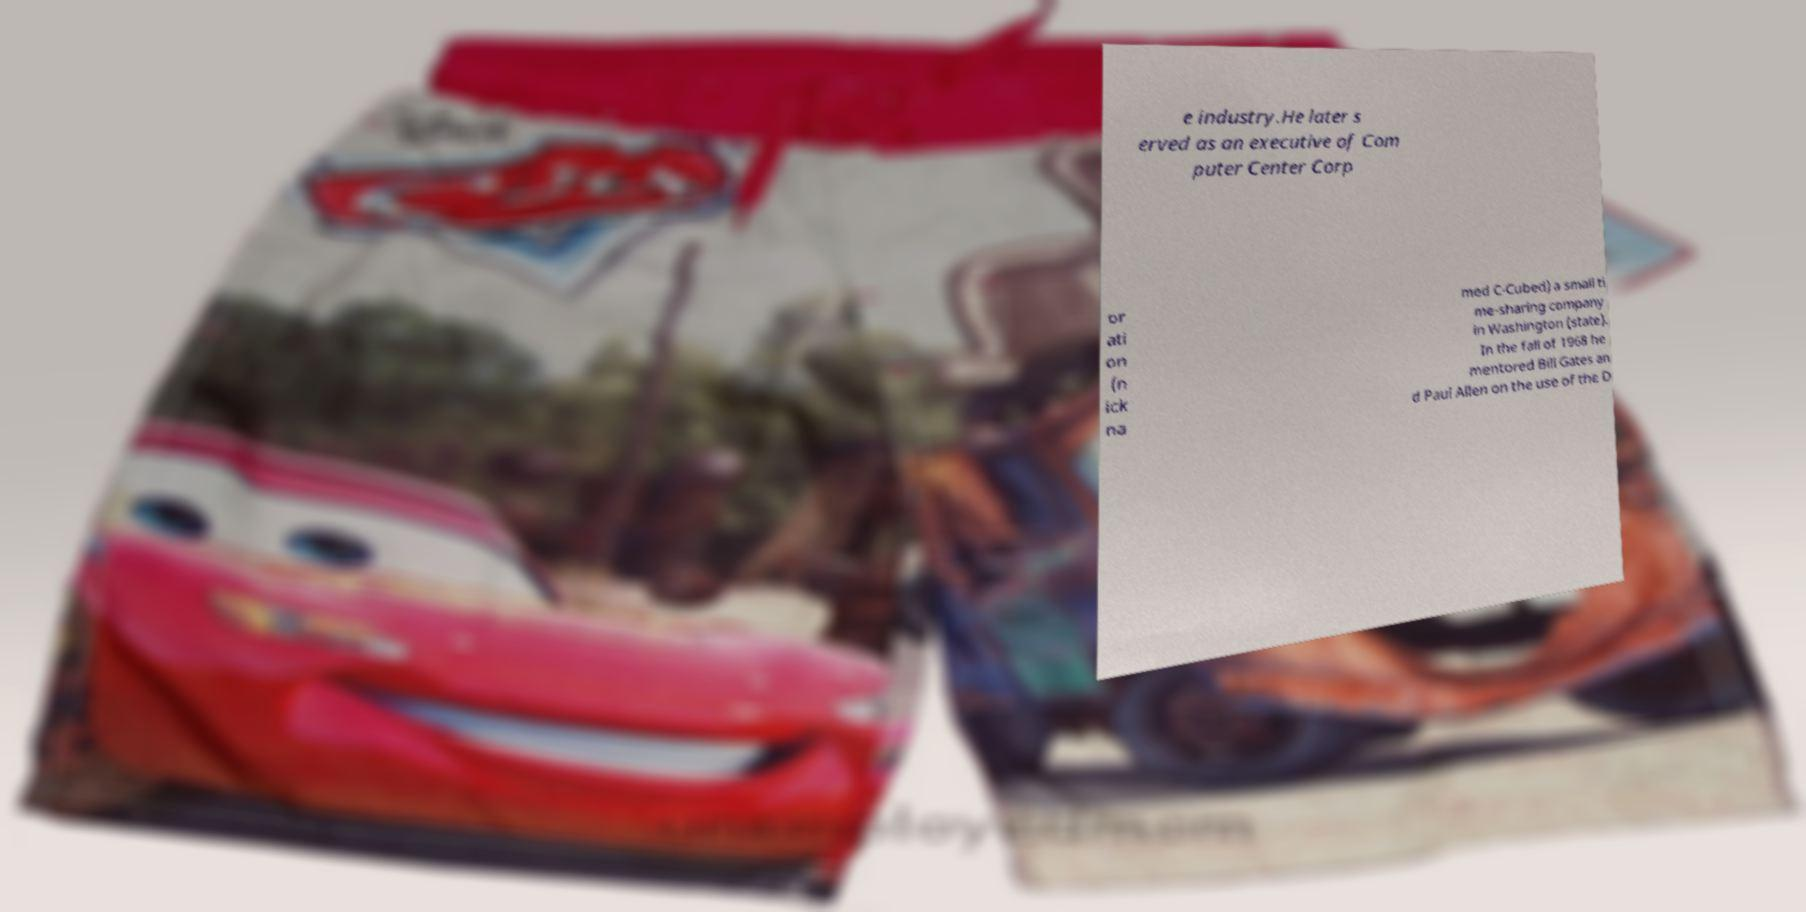Could you extract and type out the text from this image? e industry.He later s erved as an executive of Com puter Center Corp or ati on (n ick na med C-Cubed) a small ti me-sharing company in Washington (state). In the fall of 1968 he mentored Bill Gates an d Paul Allen on the use of the D 